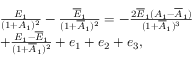<formula> <loc_0><loc_0><loc_500><loc_500>\begin{array} { r l } & { \frac { E _ { 1 } } { ( 1 + A _ { 1 } ) ^ { 2 } } - \frac { \overline { E } _ { 1 } } { ( 1 + \overline { A } _ { 1 } ) ^ { 2 } } = - \frac { 2 \overline { E } _ { 1 } ( A _ { 1 } - \overline { A } _ { 1 } ) } { ( 1 + \overline { A } _ { 1 } ) ^ { 3 } } } \\ & { + \frac { E _ { 1 } - \overline { E } _ { 1 } } { ( 1 + \overline { A } _ { 1 } ) ^ { 2 } } + e _ { 1 } + e _ { 2 } + e _ { 3 } , } \end{array}</formula> 